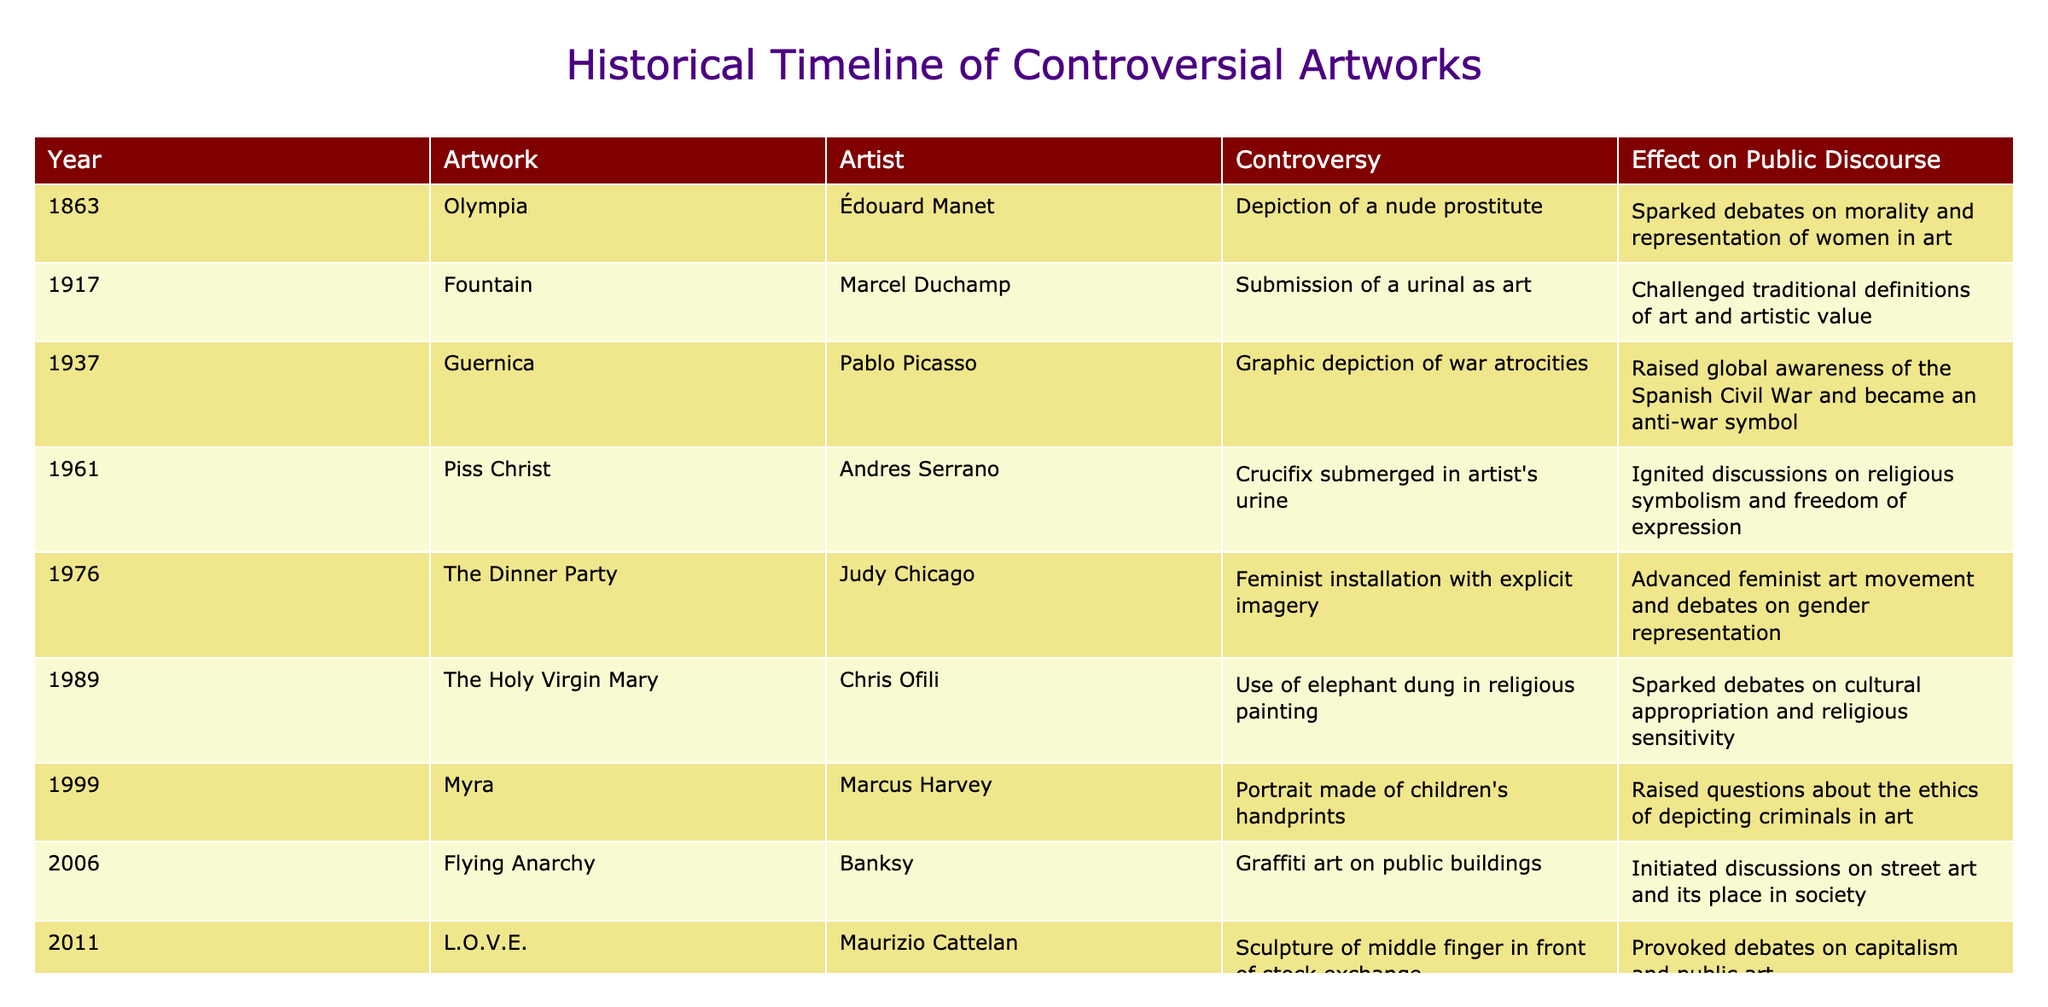What year was Piss Christ created? The table lists Piss Christ under the year 1961.
Answer: 1961 Which artist created Fountain? According to the table, Fountain was created by Marcel Duchamp.
Answer: Marcel Duchamp How many artworks were created between 1961 and 1989? The artworks listed between 1961 (Piss Christ) and 1989 (The Holy Virgin Mary) are Piss Christ, The Dinner Party, and The Holy Virgin Mary, totaling three artworks.
Answer: 3 Did any artworks listed in the table raise awareness about the Spanish Civil War? Yes, Guernica by Pablo Picasso raised global awareness of the Spanish Civil War according to the table.
Answer: Yes Which controversy sparked debates on morality and representation of women in art? The table states that the controversy surrounding Olympia by Édouard Manet sparked debates on morality and representation of women in art.
Answer: Olympia Among the artworks listed, which one ignited discussions about religious symbolism? Piss Christ by Andres Serrano ignited discussions on religious symbolism, as mentioned in the table.
Answer: Piss Christ What is the effect of the artwork Flying Anarchy on public discourse? The effect of Flying Anarchy is that it initiated discussions on street art and its place in society, according to the table.
Answer: Initiated discussions on street art Which artwork raised ethical questions about depicting criminals in art? The artwork Myra by Marcus Harvey raised ethical questions about depicting criminals in art, as stated in the table.
Answer: Myra How many artworks in the table are related to feminism? There are two artworks that are related to feminism: The Dinner Party by Judy Chicago and Fearless Girl by Kristen Visbal, making a total of two.
Answer: 2 